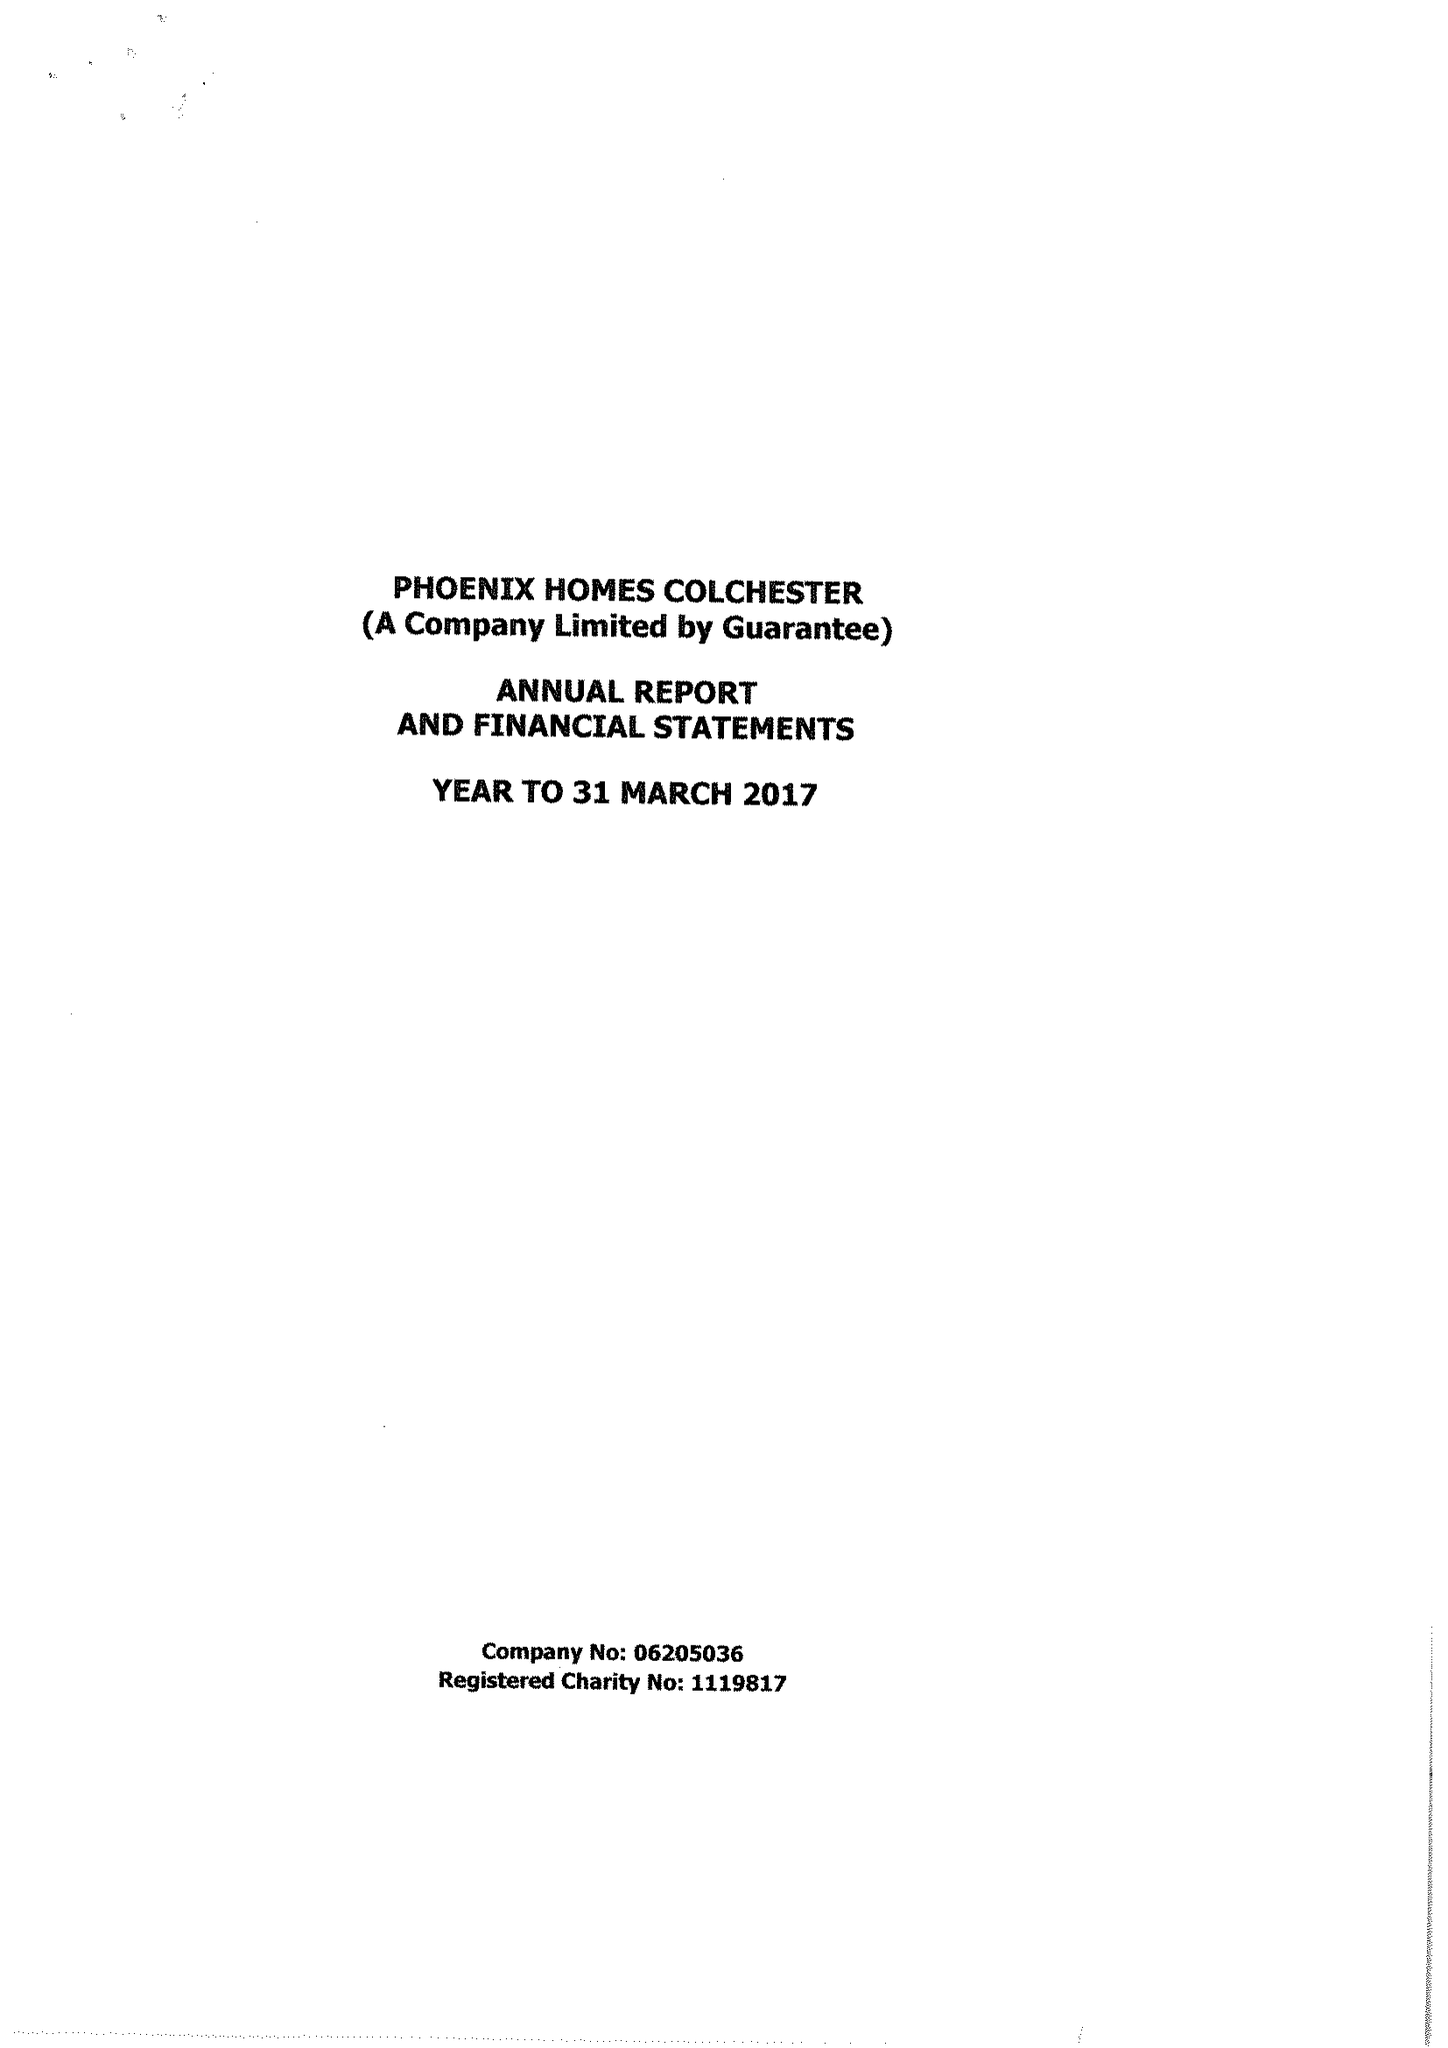What is the value for the address__post_town?
Answer the question using a single word or phrase. COLCHESTER 